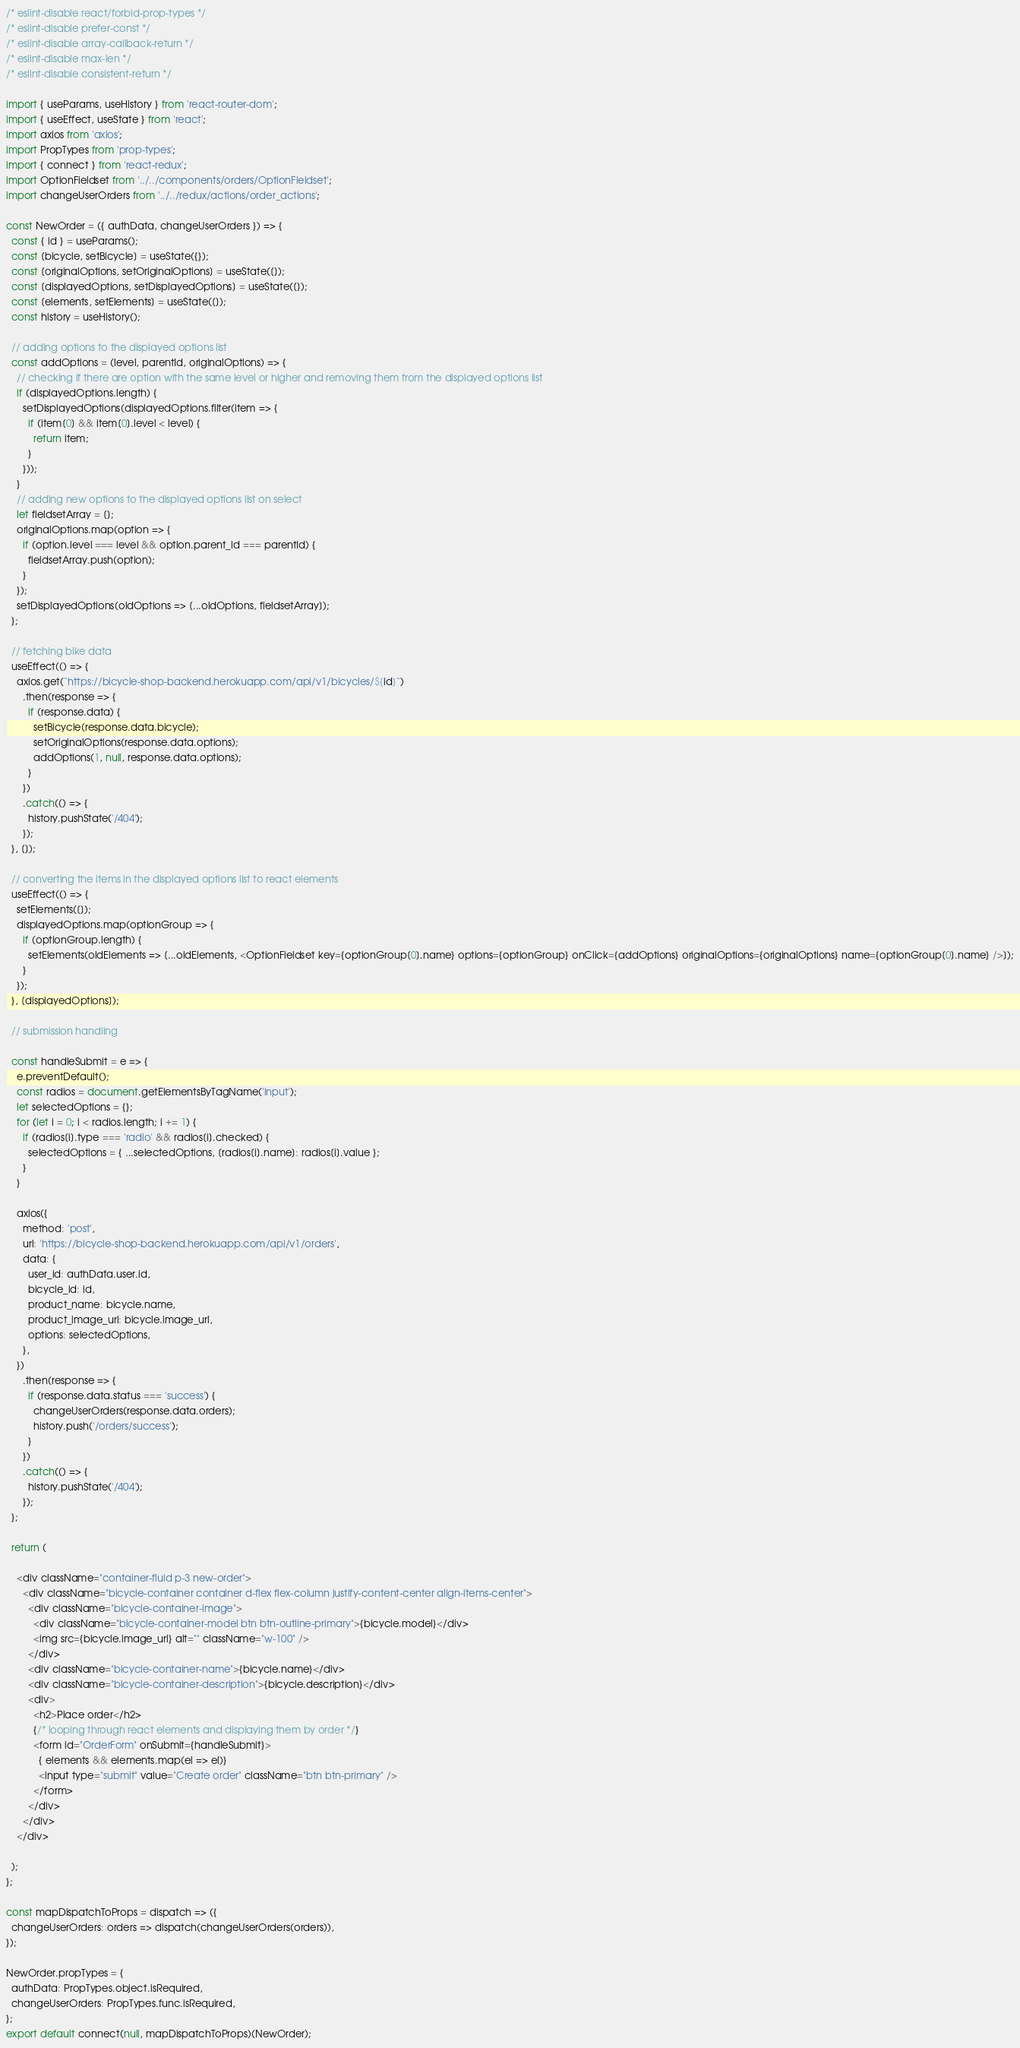Convert code to text. <code><loc_0><loc_0><loc_500><loc_500><_JavaScript_>/* eslint-disable react/forbid-prop-types */
/* eslint-disable prefer-const */
/* eslint-disable array-callback-return */
/* eslint-disable max-len */
/* eslint-disable consistent-return */

import { useParams, useHistory } from 'react-router-dom';
import { useEffect, useState } from 'react';
import axios from 'axios';
import PropTypes from 'prop-types';
import { connect } from 'react-redux';
import OptionFieldset from '../../components/orders/OptionFieldset';
import changeUserOrders from '../../redux/actions/order_actions';

const NewOrder = ({ authData, changeUserOrders }) => {
  const { id } = useParams();
  const [bicycle, setBicycle] = useState({});
  const [originalOptions, setOriginalOptions] = useState([]);
  const [displayedOptions, setDisplayedOptions] = useState([]);
  const [elements, setElements] = useState([]);
  const history = useHistory();

  // adding options to the displayed options list
  const addOptions = (level, parentId, originalOptions) => {
    // checking if there are option with the same level or higher and removing them from the displayed options list
    if (displayedOptions.length) {
      setDisplayedOptions(displayedOptions.filter(item => {
        if (item[0] && item[0].level < level) {
          return item;
        }
      }));
    }
    // adding new options to the displayed options list on select
    let fieldsetArray = [];
    originalOptions.map(option => {
      if (option.level === level && option.parent_id === parentId) {
        fieldsetArray.push(option);
      }
    });
    setDisplayedOptions(oldOptions => [...oldOptions, fieldsetArray]);
  };

  // fetching bike data
  useEffect(() => {
    axios.get(`https://bicycle-shop-backend.herokuapp.com/api/v1/bicycles/${id}`)
      .then(response => {
        if (response.data) {
          setBicycle(response.data.bicycle);
          setOriginalOptions(response.data.options);
          addOptions(1, null, response.data.options);
        }
      })
      .catch(() => {
        history.pushState('/404');
      });
  }, []);

  // converting the items in the displayed options list to react elements
  useEffect(() => {
    setElements([]);
    displayedOptions.map(optionGroup => {
      if (optionGroup.length) {
        setElements(oldElements => [...oldElements, <OptionFieldset key={optionGroup[0].name} options={optionGroup} onClick={addOptions} originalOptions={originalOptions} name={optionGroup[0].name} />]);
      }
    });
  }, [displayedOptions]);

  // submission handling

  const handleSubmit = e => {
    e.preventDefault();
    const radios = document.getElementsByTagName('input');
    let selectedOptions = {};
    for (let i = 0; i < radios.length; i += 1) {
      if (radios[i].type === 'radio' && radios[i].checked) {
        selectedOptions = { ...selectedOptions, [radios[i].name]: radios[i].value };
      }
    }

    axios({
      method: 'post',
      url: 'https://bicycle-shop-backend.herokuapp.com/api/v1/orders',
      data: {
        user_id: authData.user.id,
        bicycle_id: id,
        product_name: bicycle.name,
        product_image_url: bicycle.image_url,
        options: selectedOptions,
      },
    })
      .then(response => {
        if (response.data.status === 'success') {
          changeUserOrders(response.data.orders);
          history.push('/orders/success');
        }
      })
      .catch(() => {
        history.pushState('/404');
      });
  };

  return (

    <div className="container-fluid p-3 new-order">
      <div className="bicycle-container container d-flex flex-column justify-content-center align-items-center">
        <div className="bicycle-container-image">
          <div className="bicycle-container-model btn btn-outline-primary">{bicycle.model}</div>
          <img src={bicycle.image_url} alt="" className="w-100" />
        </div>
        <div className="bicycle-container-name">{bicycle.name}</div>
        <div className="bicycle-container-description">{bicycle.description}</div>
        <div>
          <h2>Place order</h2>
          {/* looping through react elements and displaying them by order */}
          <form id="OrderForm" onSubmit={handleSubmit}>
            { elements && elements.map(el => el)}
            <input type="submit" value="Create order" className="btn btn-primary" />
          </form>
        </div>
      </div>
    </div>

  );
};

const mapDispatchToProps = dispatch => ({
  changeUserOrders: orders => dispatch(changeUserOrders(orders)),
});

NewOrder.propTypes = {
  authData: PropTypes.object.isRequired,
  changeUserOrders: PropTypes.func.isRequired,
};
export default connect(null, mapDispatchToProps)(NewOrder);
</code> 